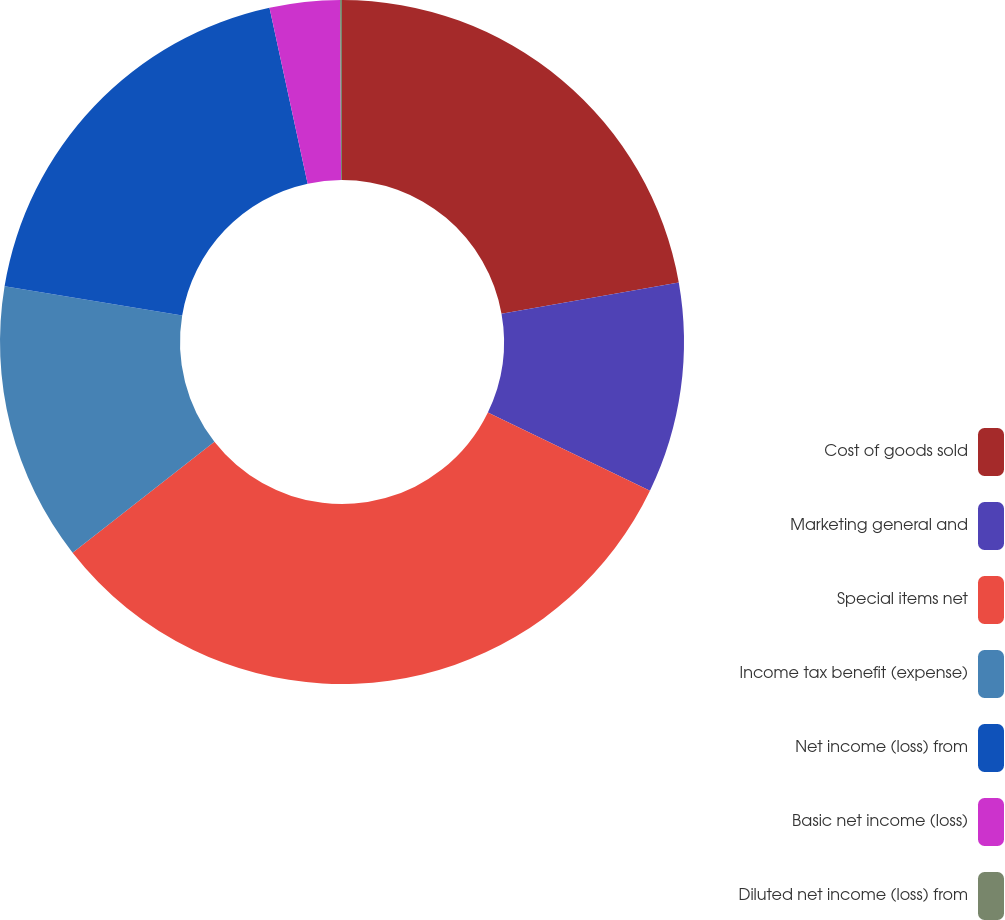<chart> <loc_0><loc_0><loc_500><loc_500><pie_chart><fcel>Cost of goods sold<fcel>Marketing general and<fcel>Special items net<fcel>Income tax benefit (expense)<fcel>Net income (loss) from<fcel>Basic net income (loss)<fcel>Diluted net income (loss) from<nl><fcel>22.21%<fcel>9.95%<fcel>32.27%<fcel>13.17%<fcel>18.99%<fcel>3.31%<fcel>0.09%<nl></chart> 